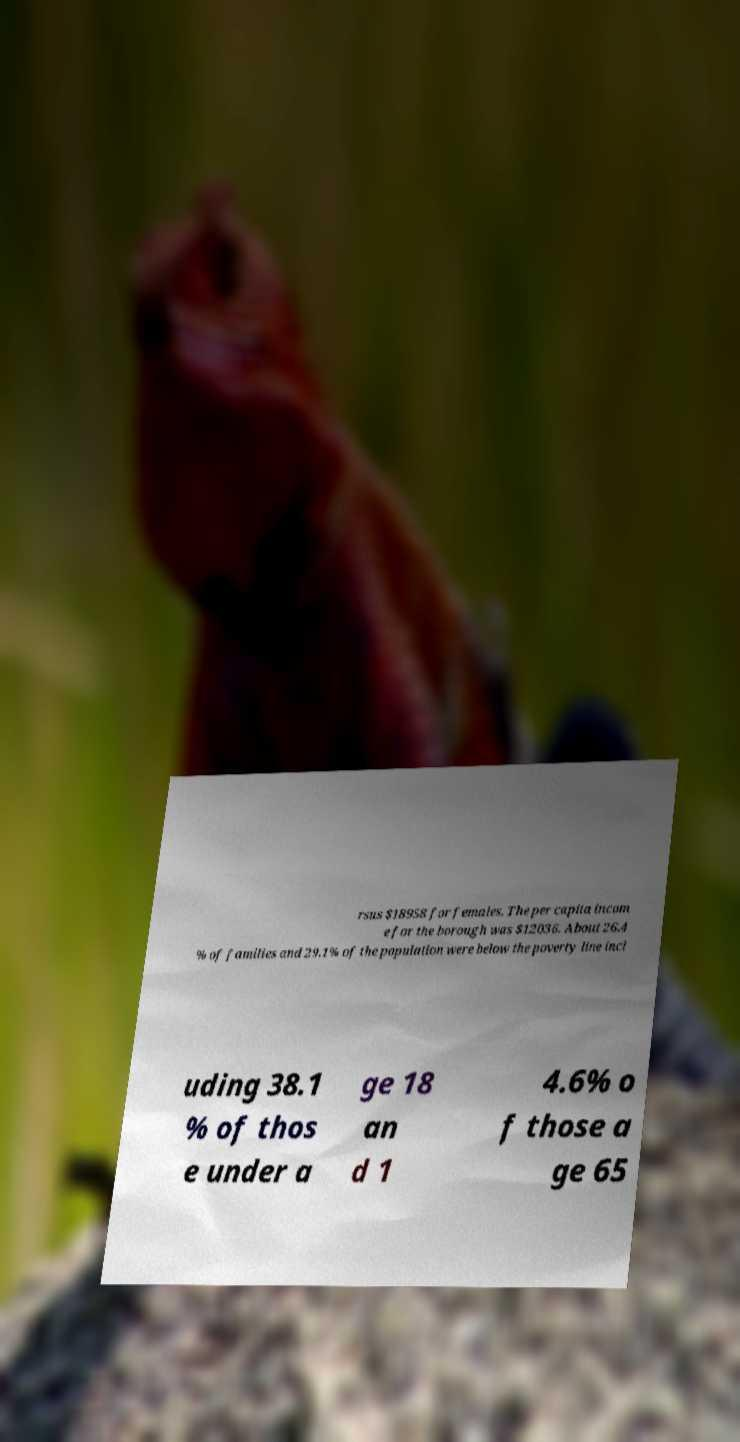Please identify and transcribe the text found in this image. rsus $18958 for females. The per capita incom e for the borough was $12036. About 26.4 % of families and 29.1% of the population were below the poverty line incl uding 38.1 % of thos e under a ge 18 an d 1 4.6% o f those a ge 65 